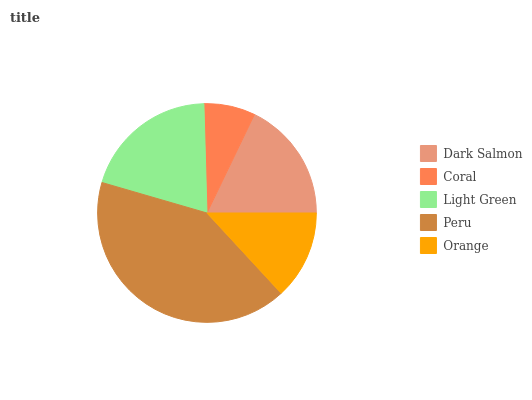Is Coral the minimum?
Answer yes or no. Yes. Is Peru the maximum?
Answer yes or no. Yes. Is Light Green the minimum?
Answer yes or no. No. Is Light Green the maximum?
Answer yes or no. No. Is Light Green greater than Coral?
Answer yes or no. Yes. Is Coral less than Light Green?
Answer yes or no. Yes. Is Coral greater than Light Green?
Answer yes or no. No. Is Light Green less than Coral?
Answer yes or no. No. Is Dark Salmon the high median?
Answer yes or no. Yes. Is Dark Salmon the low median?
Answer yes or no. Yes. Is Orange the high median?
Answer yes or no. No. Is Light Green the low median?
Answer yes or no. No. 